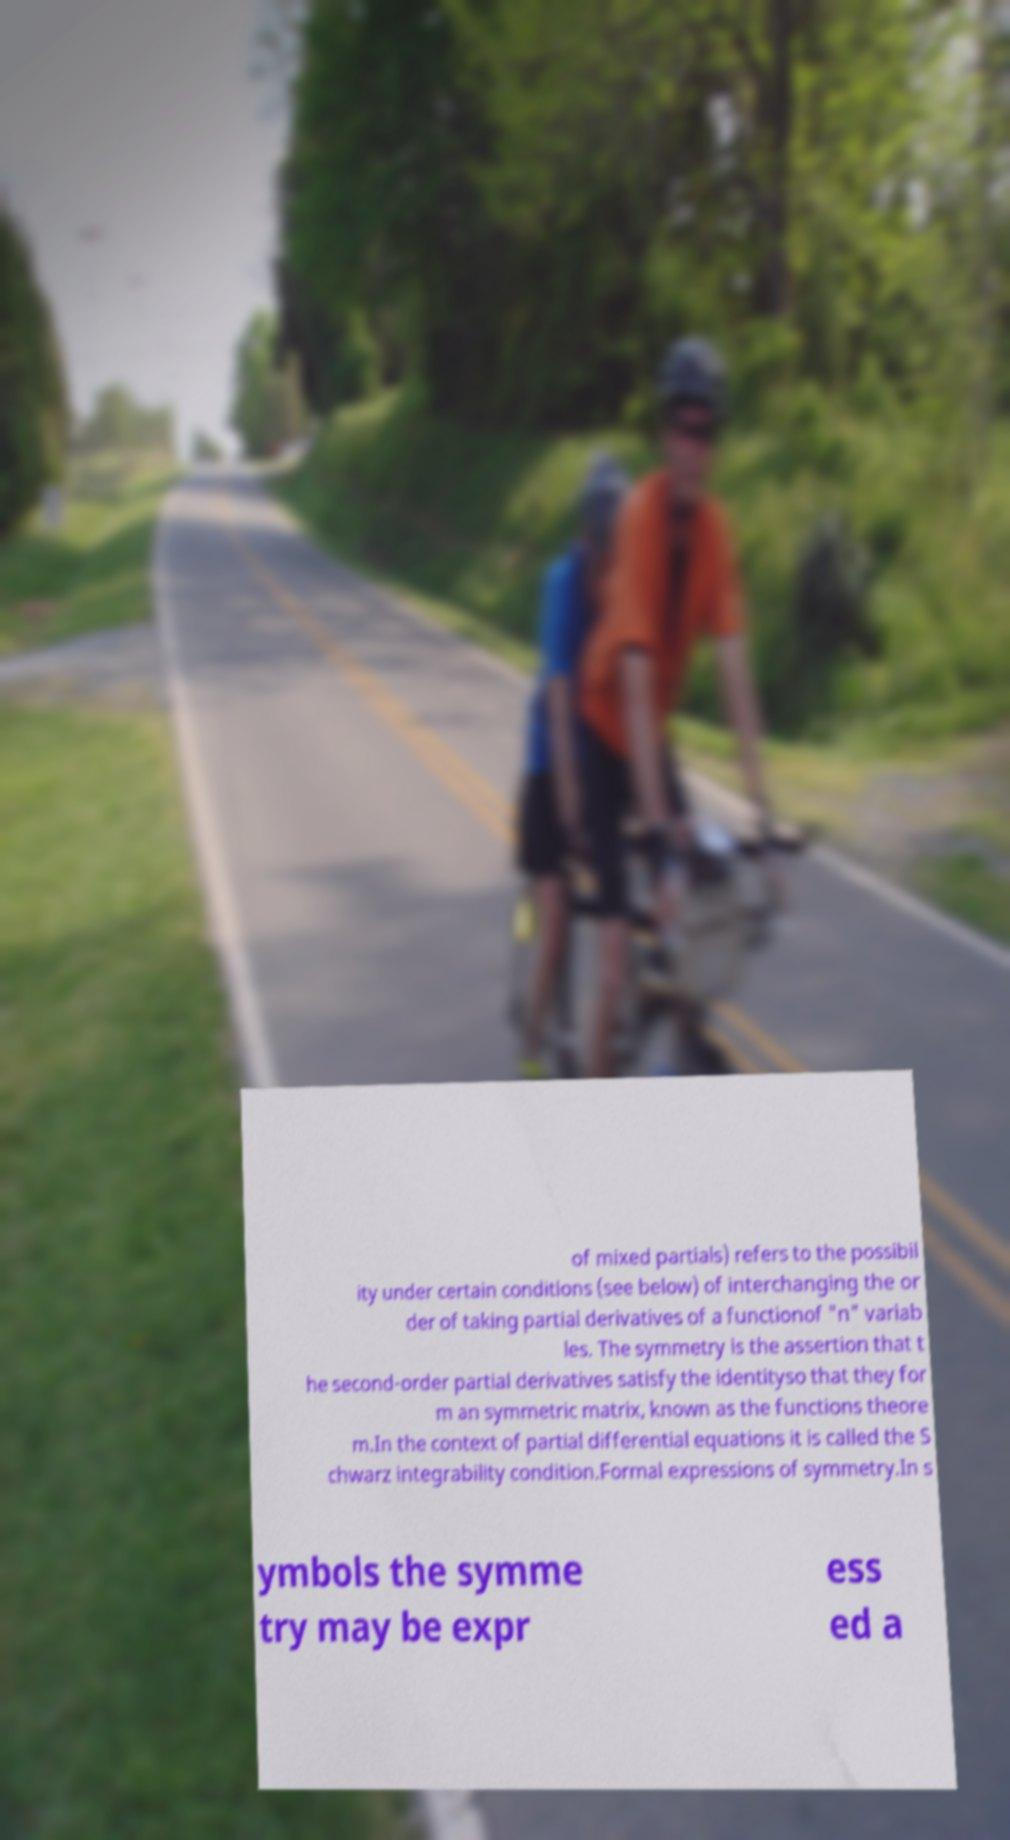Please identify and transcribe the text found in this image. of mixed partials) refers to the possibil ity under certain conditions (see below) of interchanging the or der of taking partial derivatives of a functionof "n" variab les. The symmetry is the assertion that t he second-order partial derivatives satisfy the identityso that they for m an symmetric matrix, known as the functions theore m.In the context of partial differential equations it is called the S chwarz integrability condition.Formal expressions of symmetry.In s ymbols the symme try may be expr ess ed a 